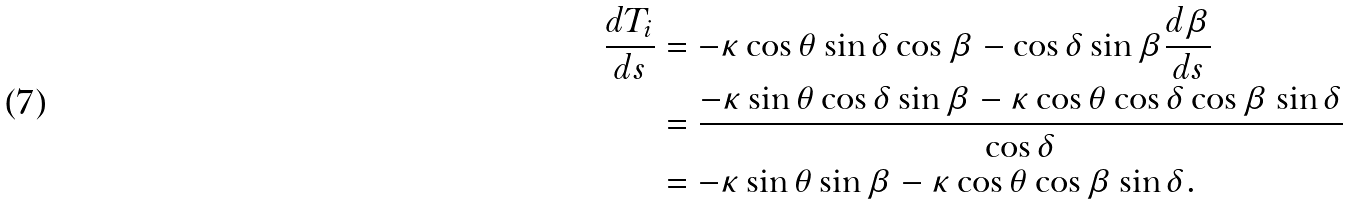<formula> <loc_0><loc_0><loc_500><loc_500>\frac { d T _ { i } } { d s } & = - \kappa \cos \theta \sin \delta \cos \beta - \cos \delta \sin \beta \frac { d \beta } { d s } \\ & = \frac { - \kappa \sin \theta \cos \delta \sin \beta - \kappa \cos \theta \cos \delta \cos \beta \sin \delta } { \cos \delta } \\ & = - \kappa \sin \theta \sin \beta - \kappa \cos \theta \cos \beta \sin \delta .</formula> 